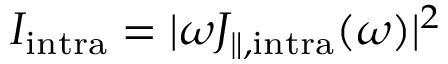Convert formula to latex. <formula><loc_0><loc_0><loc_500><loc_500>I _ { i n t r a } = | \omega J _ { \| , i n t r a } ( \omega ) | ^ { 2 }</formula> 